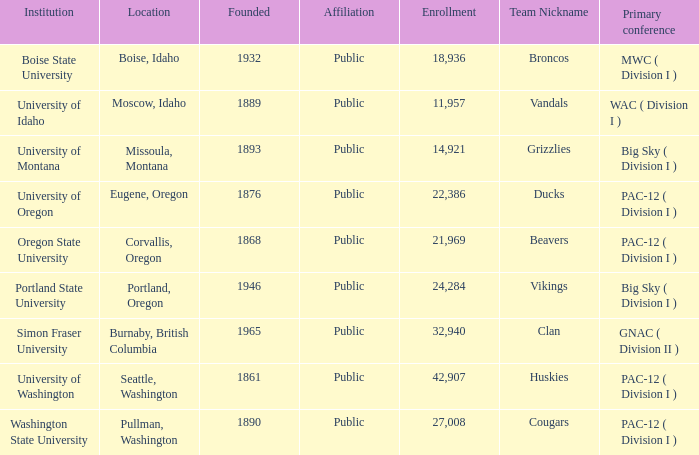In which place is the broncos team, formed sometime after 1889, situated? Boise, Idaho. 